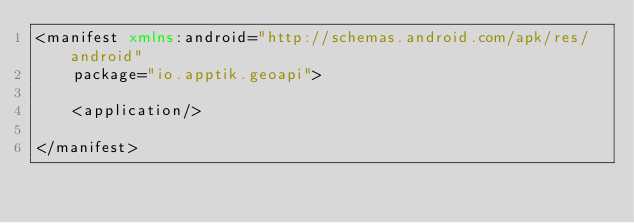Convert code to text. <code><loc_0><loc_0><loc_500><loc_500><_XML_><manifest xmlns:android="http://schemas.android.com/apk/res/android"
    package="io.apptik.geoapi">

    <application/>

</manifest>
</code> 